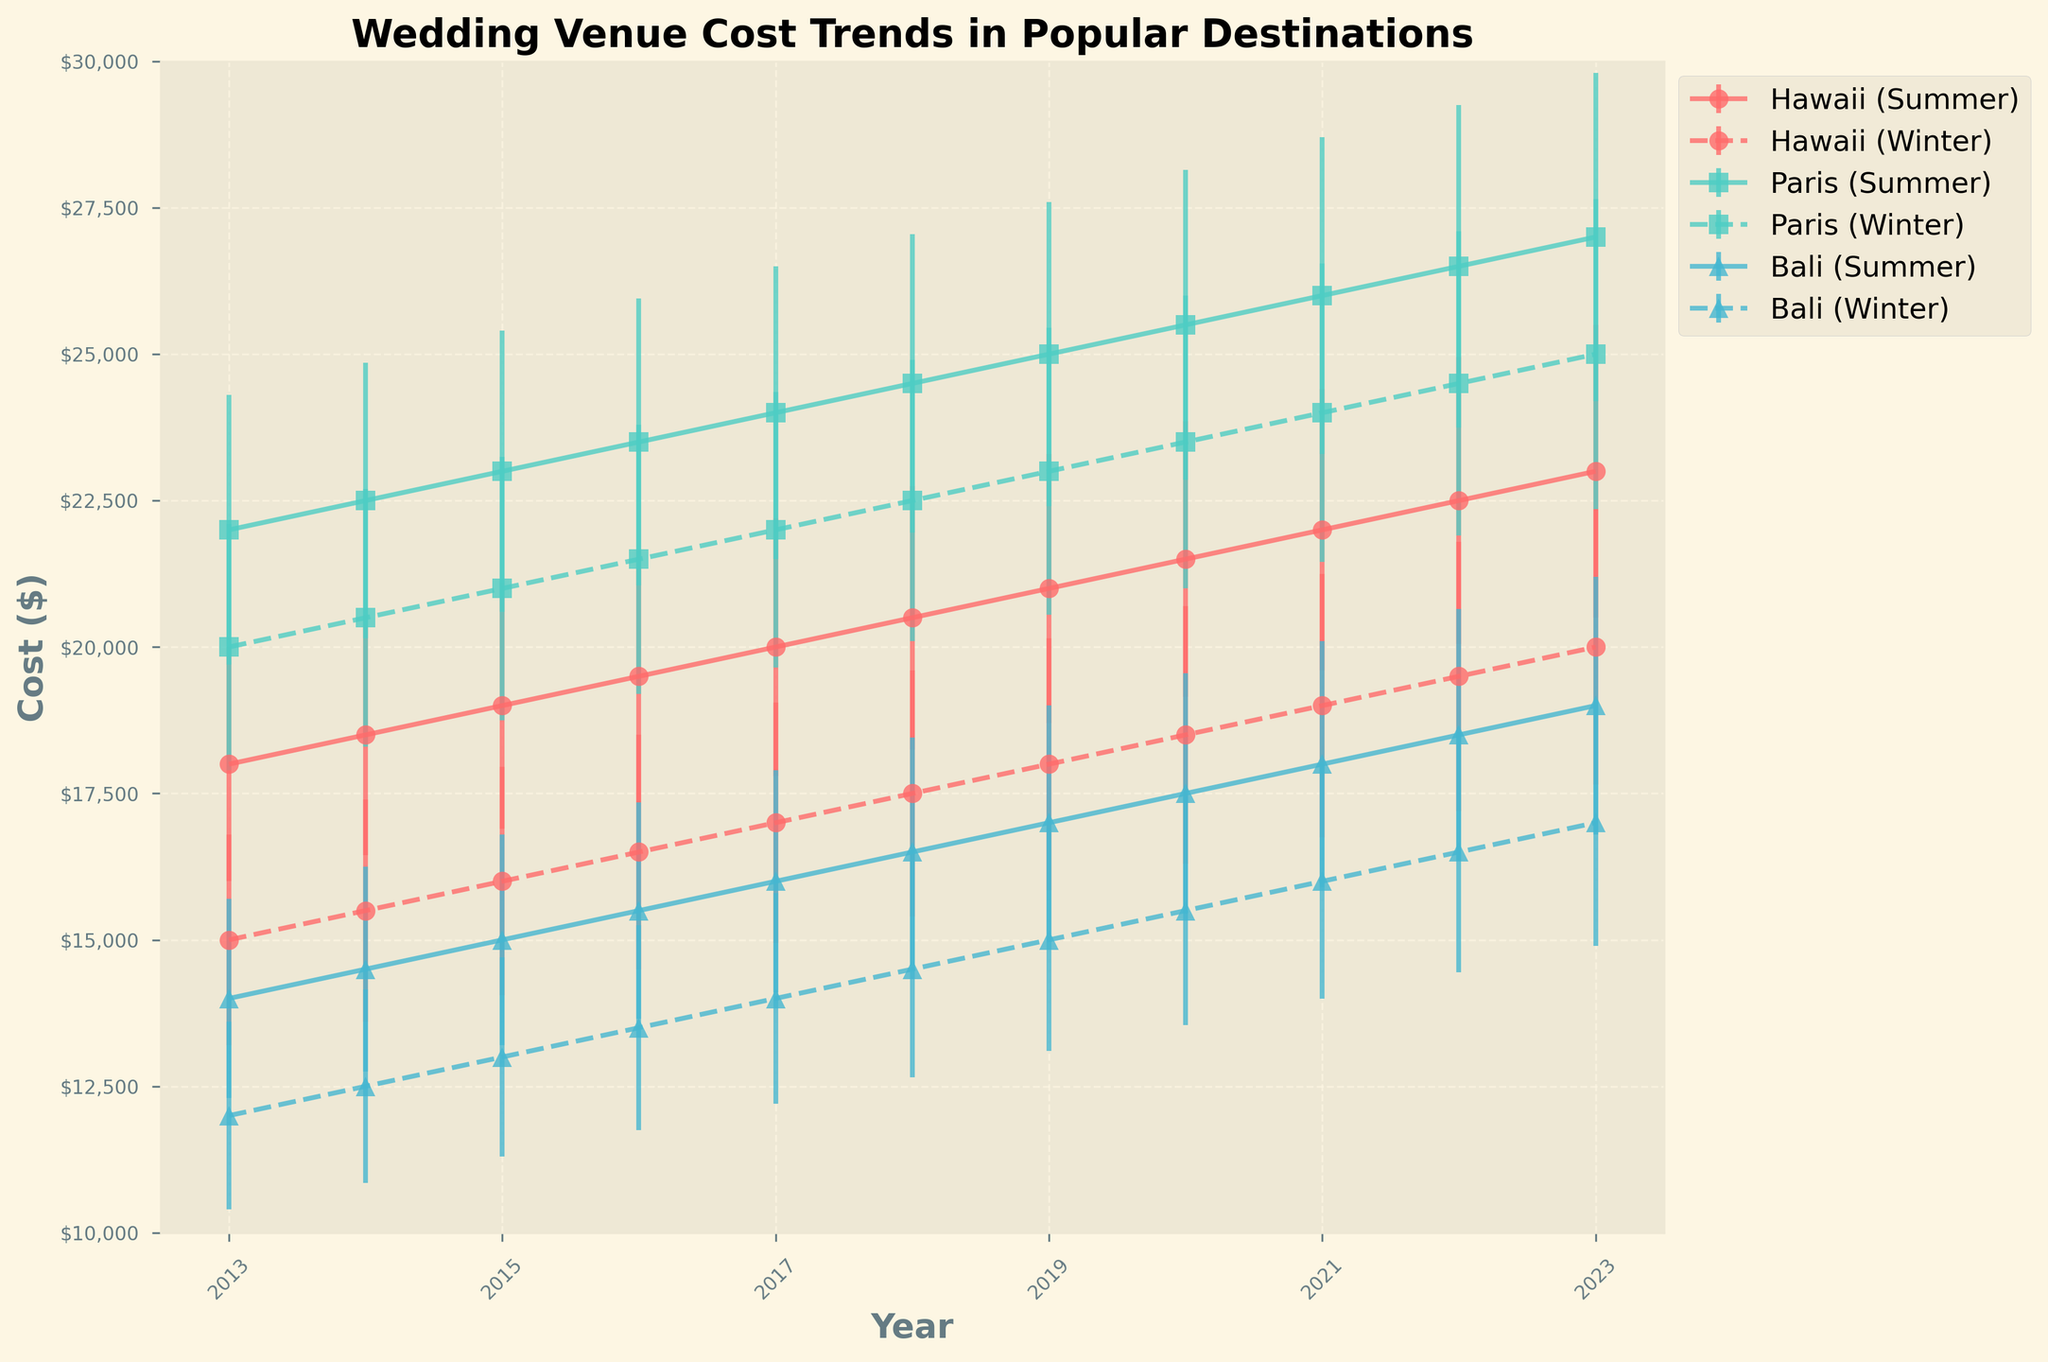What's the title of the figure? The title of the figure is usually located at the top of the graph. In this case, it is clearly visible.
Answer: Wedding Venue Cost Trends in Popular Destinations What is the general trend for wedding costs in Bali during the summer from 2013 to 2023? By observing the line plot for Bali during the summer, there is a clear upward trend in the cost over the years.
Answer: Increasing Between Paris in the summer and winter of 2022, which season was more expensive for wedding venues? By comparing the error bars for Paris in both seasons in 2022, it is evident that the summer season has a higher cost than the winter season.
Answer: Summer What was the cost range for a wedding venue in Hawaii during the summer of 2021, given the error bars? To determine the range, add and subtract the standard deviation (2400) from the cost (22000). This results in a range from 19600 to 24400.
Answer: $19600 - $24400 How does the cost fluctuation in Paris during the winter compare from 2015 to 2016? By examining the error bars from 2015 to 2016 for Paris in winter, we note that the costs rose from 21000 to 21500, with slight increases in error margins.
Answer: Slight increase When comparing the costs of having a wedding in Bali during the winter season from 2015 to 2020, what is the cost difference between 2015 and 2020? The cost in Bali during winter in 2015 is $13000, while in 2020 it is $15500, giving a difference of $2500.
Answer: $2500 Were there any years where the cost error bars for summer weddings in Paris overlapped with those of winter weddings? By examining the overlays, in 2013, 2014, and 2015, the error bars for both seasons show some overlap.
Answer: Yes What location and season had the least cost variance in 2019? To determine this, examine the error bars for all locations and seasons in 2019. Bali in winter had the smallest error margin (1900).
Answer: Bali (Winter) Describe the cost trend in wedding venues for Hawaii during winter from 2013 to 2023. Observing the error bars over the years, there is a steady increase from $15000 in 2013 to $20000 in 2023.
Answer: Steadily increasing 